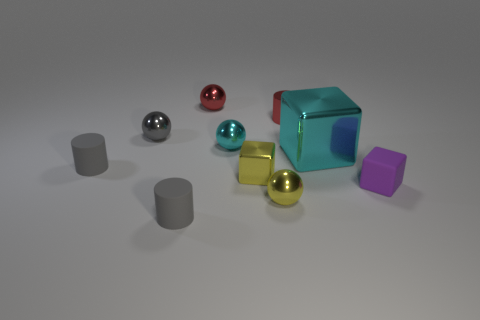There is a cyan metal object that is on the right side of the small cyan shiny ball; are there any cyan spheres in front of it? Based on the image, directly in front of the cyan metal object, there are no cyan spheres. All spheres present, including the red, silver, and gold ones, are positioned either at the side or behind the cyan object relative to the viewer's perspective. 